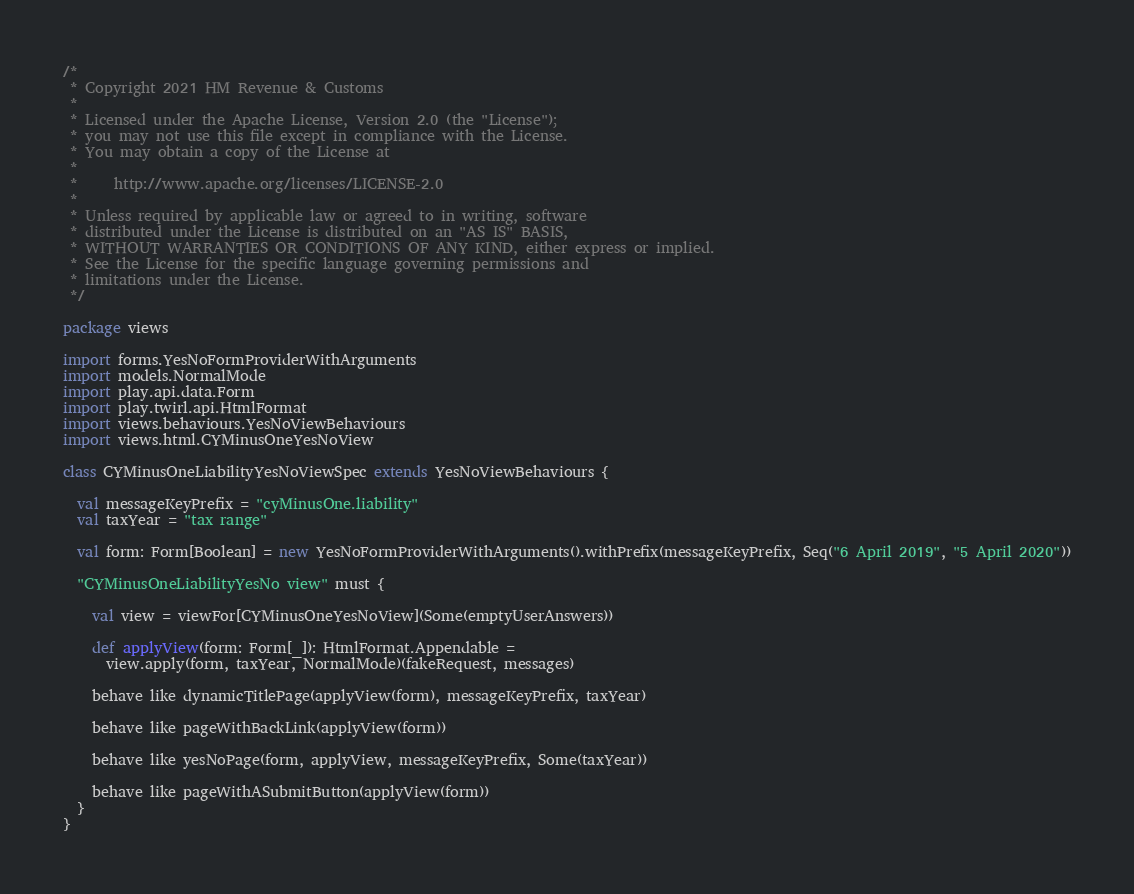Convert code to text. <code><loc_0><loc_0><loc_500><loc_500><_Scala_>/*
 * Copyright 2021 HM Revenue & Customs
 *
 * Licensed under the Apache License, Version 2.0 (the "License");
 * you may not use this file except in compliance with the License.
 * You may obtain a copy of the License at
 *
 *     http://www.apache.org/licenses/LICENSE-2.0
 *
 * Unless required by applicable law or agreed to in writing, software
 * distributed under the License is distributed on an "AS IS" BASIS,
 * WITHOUT WARRANTIES OR CONDITIONS OF ANY KIND, either express or implied.
 * See the License for the specific language governing permissions and
 * limitations under the License.
 */

package views

import forms.YesNoFormProviderWithArguments
import models.NormalMode
import play.api.data.Form
import play.twirl.api.HtmlFormat
import views.behaviours.YesNoViewBehaviours
import views.html.CYMinusOneYesNoView

class CYMinusOneLiabilityYesNoViewSpec extends YesNoViewBehaviours {

  val messageKeyPrefix = "cyMinusOne.liability"
  val taxYear = "tax range"

  val form: Form[Boolean] = new YesNoFormProviderWithArguments().withPrefix(messageKeyPrefix, Seq("6 April 2019", "5 April 2020"))

  "CYMinusOneLiabilityYesNo view" must {

    val view = viewFor[CYMinusOneYesNoView](Some(emptyUserAnswers))

    def applyView(form: Form[_]): HtmlFormat.Appendable =
      view.apply(form, taxYear, NormalMode)(fakeRequest, messages)

    behave like dynamicTitlePage(applyView(form), messageKeyPrefix, taxYear)

    behave like pageWithBackLink(applyView(form))

    behave like yesNoPage(form, applyView, messageKeyPrefix, Some(taxYear))

    behave like pageWithASubmitButton(applyView(form))
  }
}
</code> 